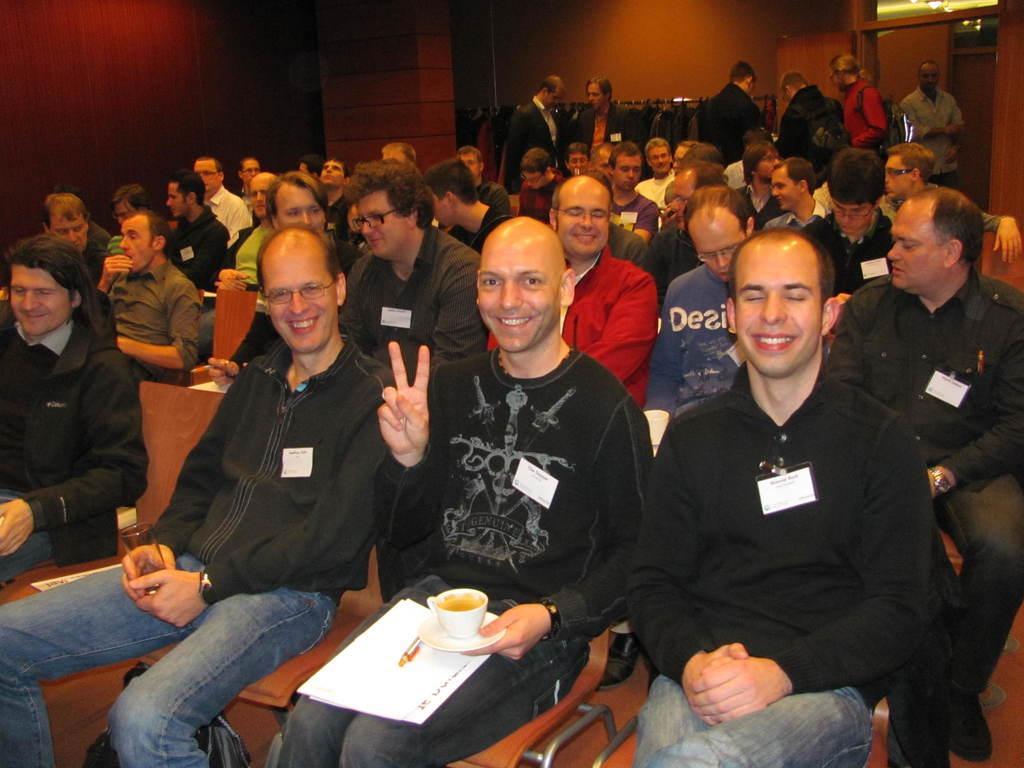Describe this image in one or two sentences. In this image I see number of people in which most of them are sitting on chairs and rest of them are standing and I see that few men are smiling and I see that this man is holding a cup and a saucer in his hand and this man is holding a glass in his hands. In the background I see the wall and I see the lights over here. 